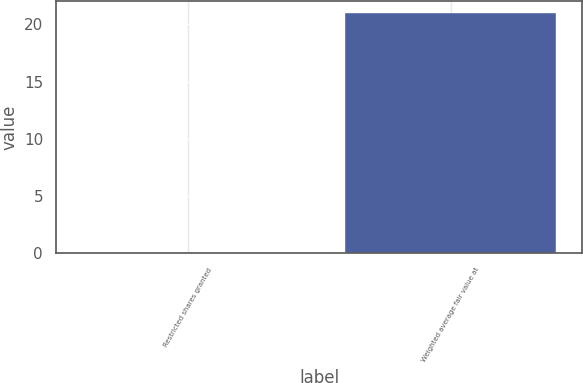Convert chart to OTSL. <chart><loc_0><loc_0><loc_500><loc_500><bar_chart><fcel>Restricted shares granted<fcel>Weighted average fair value at<nl><fcel>0.03<fcel>21.02<nl></chart> 